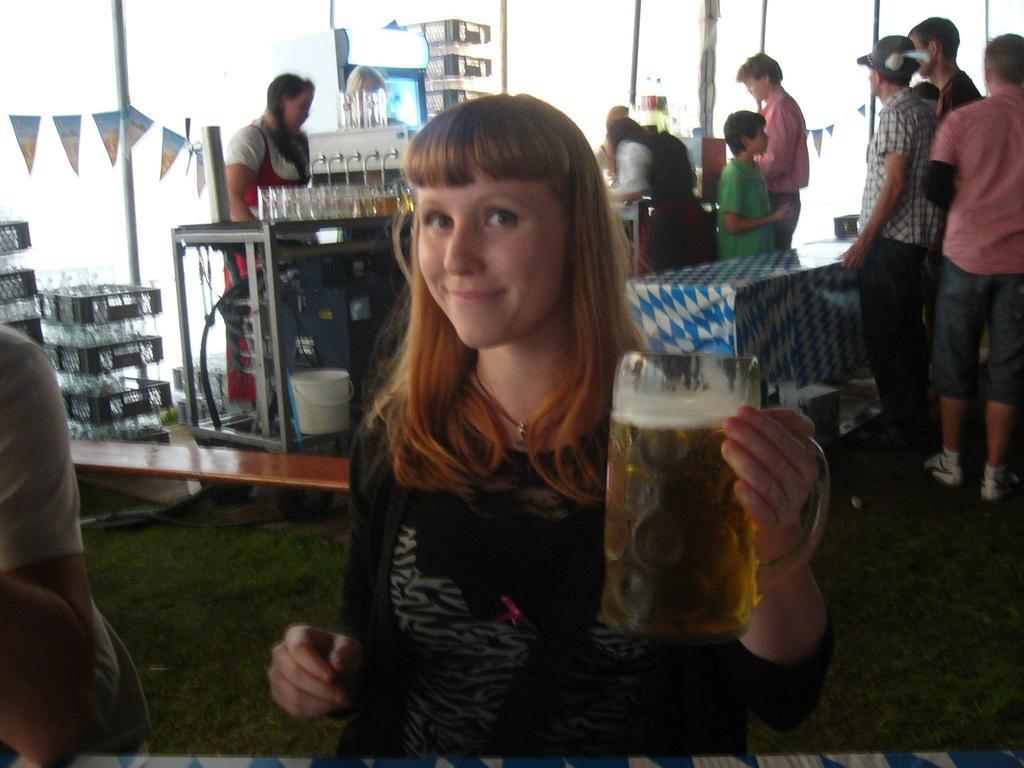Can you describe this image briefly? In this image I can see a woman is holding a wine glass in her hand. In the background I can see few people are standing in front of the table. On the left side there are some trays. 